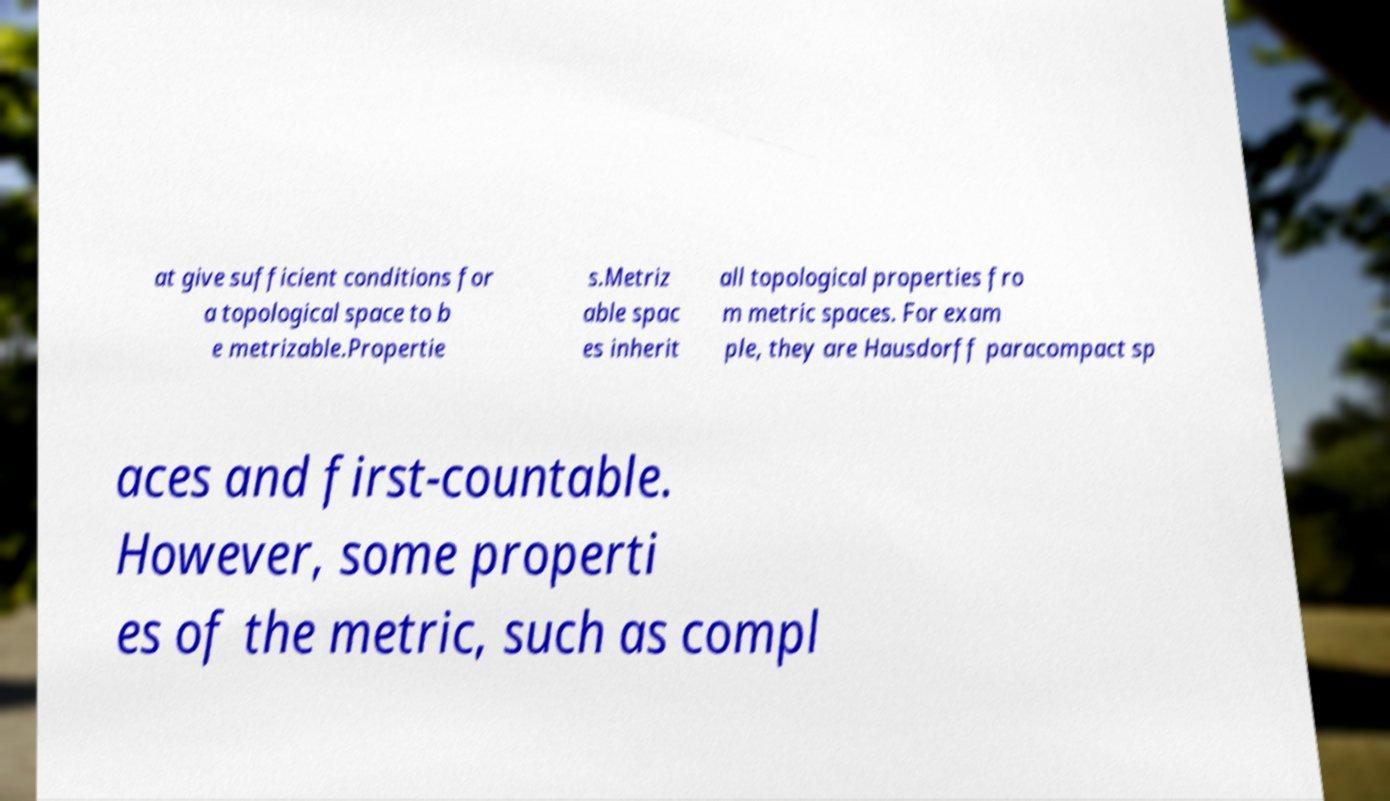There's text embedded in this image that I need extracted. Can you transcribe it verbatim? at give sufficient conditions for a topological space to b e metrizable.Propertie s.Metriz able spac es inherit all topological properties fro m metric spaces. For exam ple, they are Hausdorff paracompact sp aces and first-countable. However, some properti es of the metric, such as compl 